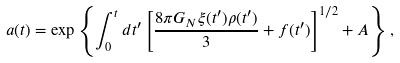Convert formula to latex. <formula><loc_0><loc_0><loc_500><loc_500>a ( t ) = \exp \left \{ \int _ { 0 } ^ { t } d t ^ { \prime } \left [ \frac { 8 \pi G _ { N } \xi ( t ^ { \prime } ) \rho ( t ^ { \prime } ) } { 3 } + f ( t ^ { \prime } ) \right ] ^ { 1 / 2 } + A \right \} ,</formula> 